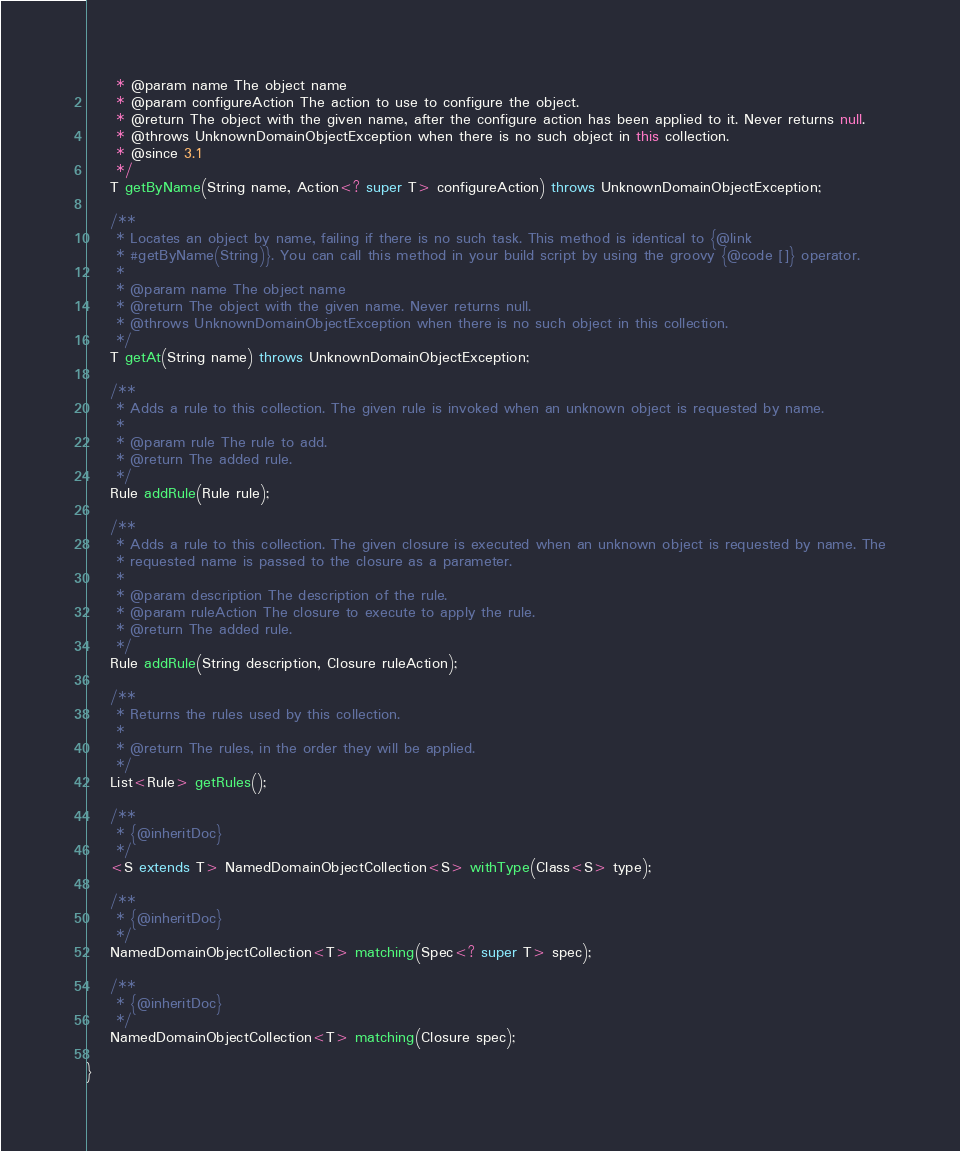Convert code to text. <code><loc_0><loc_0><loc_500><loc_500><_Java_>     * @param name The object name
     * @param configureAction The action to use to configure the object.
     * @return The object with the given name, after the configure action has been applied to it. Never returns null.
     * @throws UnknownDomainObjectException when there is no such object in this collection.
     * @since 3.1
     */
    T getByName(String name, Action<? super T> configureAction) throws UnknownDomainObjectException;

    /**
     * Locates an object by name, failing if there is no such task. This method is identical to {@link
     * #getByName(String)}. You can call this method in your build script by using the groovy {@code []} operator.
     *
     * @param name The object name
     * @return The object with the given name. Never returns null.
     * @throws UnknownDomainObjectException when there is no such object in this collection.
     */
    T getAt(String name) throws UnknownDomainObjectException;

    /**
     * Adds a rule to this collection. The given rule is invoked when an unknown object is requested by name.
     *
     * @param rule The rule to add.
     * @return The added rule.
     */
    Rule addRule(Rule rule);

    /**
     * Adds a rule to this collection. The given closure is executed when an unknown object is requested by name. The
     * requested name is passed to the closure as a parameter.
     *
     * @param description The description of the rule.
     * @param ruleAction The closure to execute to apply the rule.
     * @return The added rule.
     */
    Rule addRule(String description, Closure ruleAction);

    /**
     * Returns the rules used by this collection.
     *
     * @return The rules, in the order they will be applied.
     */
    List<Rule> getRules();

    /**
     * {@inheritDoc}
     */
    <S extends T> NamedDomainObjectCollection<S> withType(Class<S> type);

    /**
     * {@inheritDoc}
     */
    NamedDomainObjectCollection<T> matching(Spec<? super T> spec);

    /**
     * {@inheritDoc}
     */
    NamedDomainObjectCollection<T> matching(Closure spec);

}
</code> 